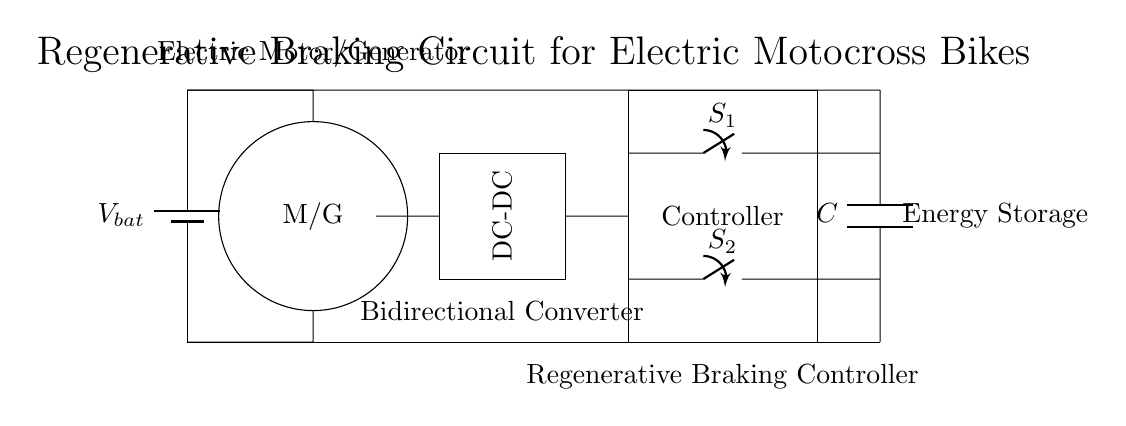What type of circuit is shown? The circuit is a regenerative braking circuit designed for electric motocross bikes, which allows energy recovery during braking.
Answer: Regenerative braking circuit What is the role of the motor/generator? The motor/generator (labeled M/G) serves a dual purpose: it operates as a motor during acceleration and acts as a generator to recover energy during braking.
Answer: Motor/Generator How many switches are present in the circuit? There are two switches present in the circuit, indicated by the symbols labeled S1 and S2.
Answer: Two What component is used for energy storage? The component used for energy storage in the circuit is a capacitor, as indicated by the symbol labeled C.
Answer: Capacitor What is the function of the DC-DC converter? The DC-DC converter alters the voltage levels in the circuit, which is essential for efficient energy transfer between components, especially when recovering energy.
Answer: Alters voltage Explain why regenerative braking can extend battery life. Regenerative braking extends battery life by converting kinetic energy into electrical energy during braking, which is then stored back into the battery or capacitor for future use, reducing reliance on the battery.
Answer: It converts energy during braking 